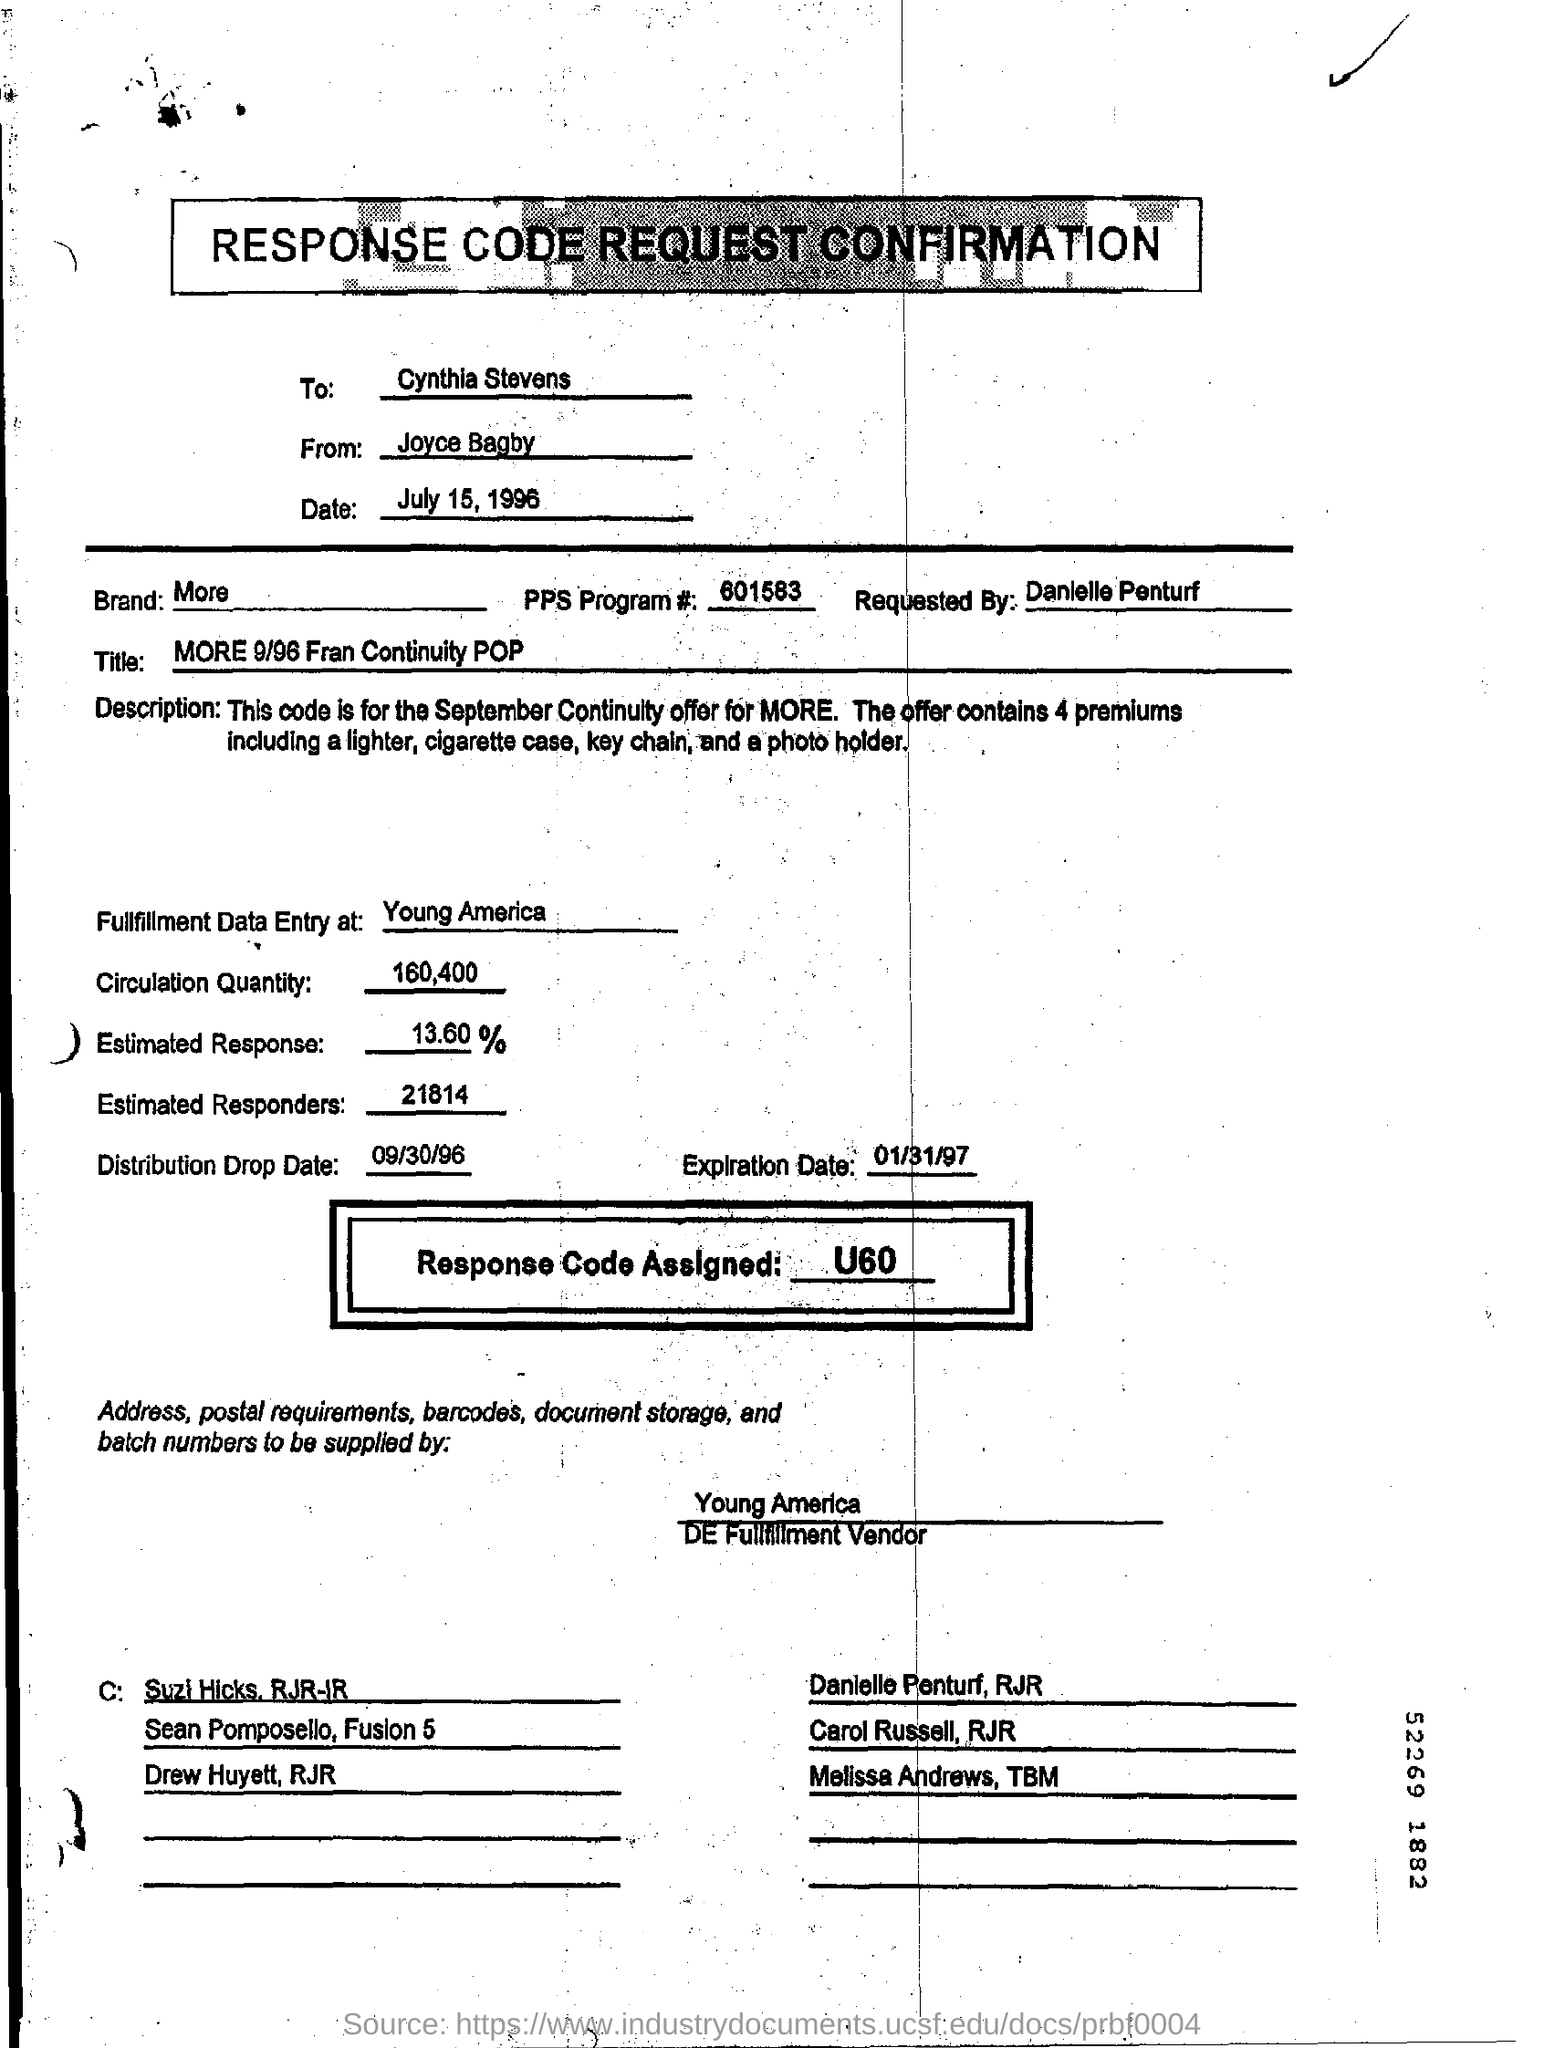Which brand is mentioned in the form?
Keep it short and to the point. More. Who sent this ?
Keep it short and to the point. Joyce Bagby. What is the PPS program Number ?
Provide a succinct answer. 601583. Who is the recipient ?
Provide a short and direct response. Cynthia Stevens. What is written in the Brand Field ?
Keep it short and to the point. More. What is written in the Title Field ?
Your response must be concise. MORE 9/96 Fran Continuity POP. What is the Distribution Drop Date ?
Provide a succinct answer. 09/30/96. What is written in Response Code Assigned  Field ?
Your response must be concise. U60. What is written in the Circulation Quantity Field ?
Your response must be concise. 160,400. 